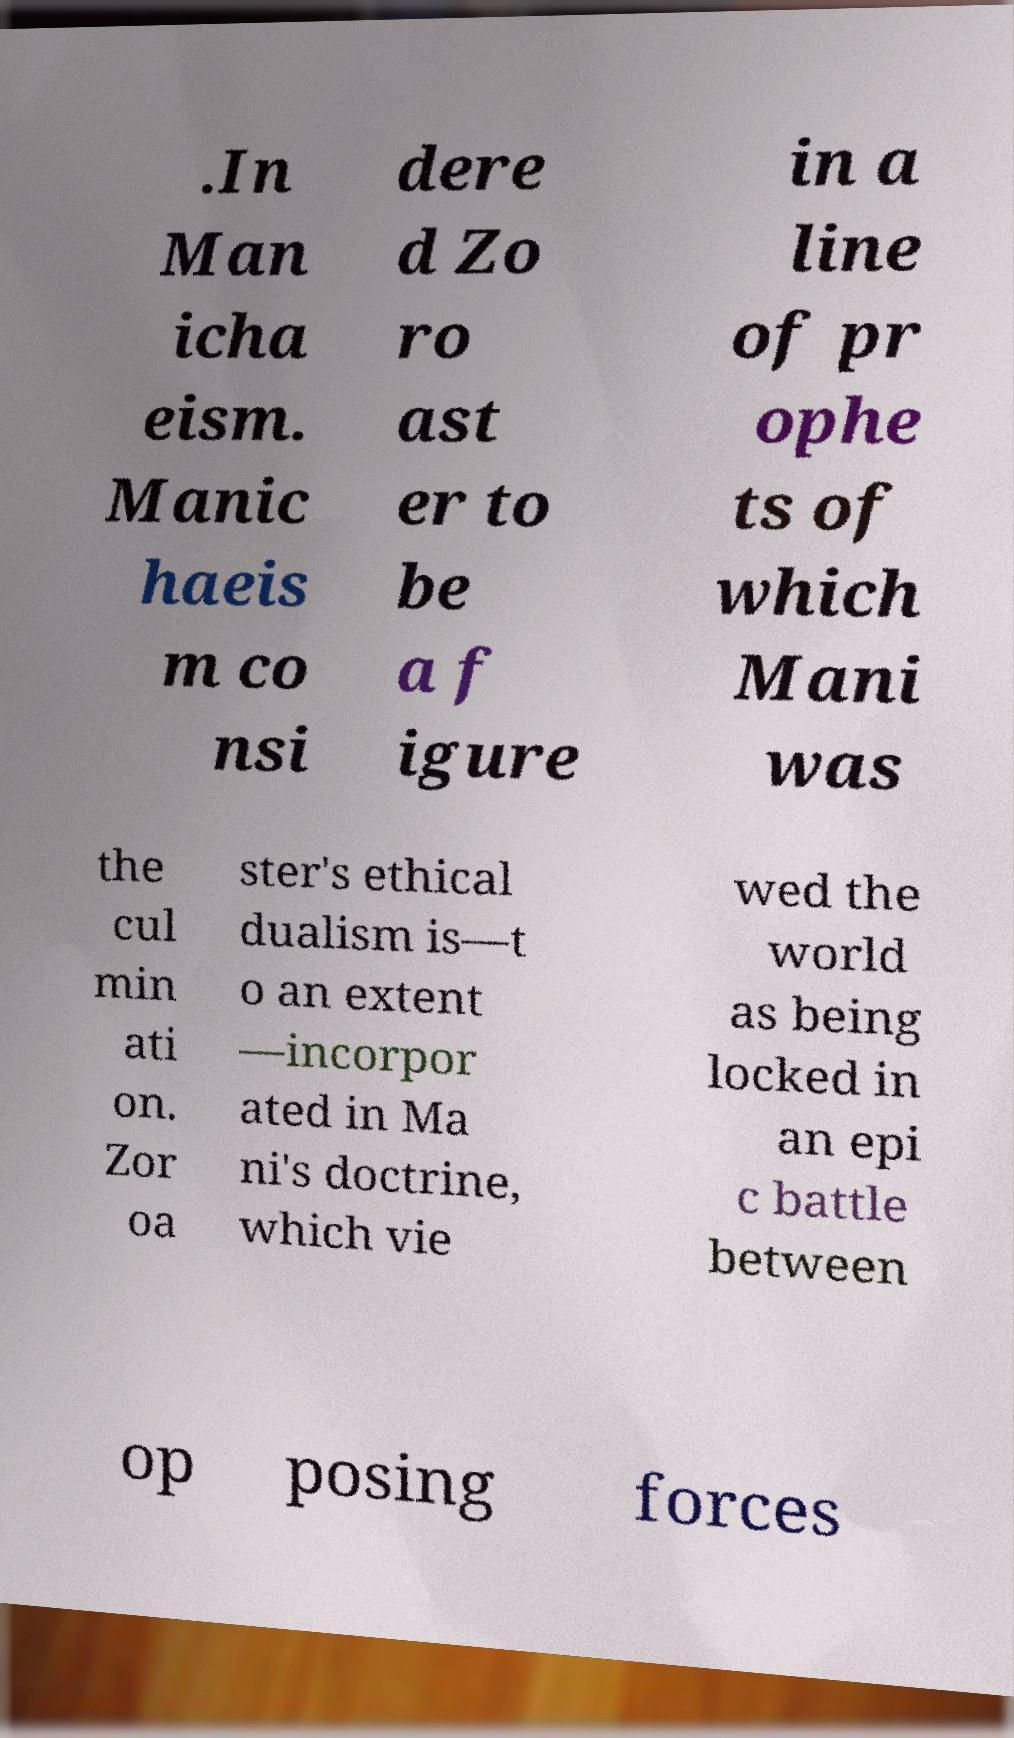Please read and relay the text visible in this image. What does it say? .In Man icha eism. Manic haeis m co nsi dere d Zo ro ast er to be a f igure in a line of pr ophe ts of which Mani was the cul min ati on. Zor oa ster's ethical dualism is—t o an extent —incorpor ated in Ma ni's doctrine, which vie wed the world as being locked in an epi c battle between op posing forces 